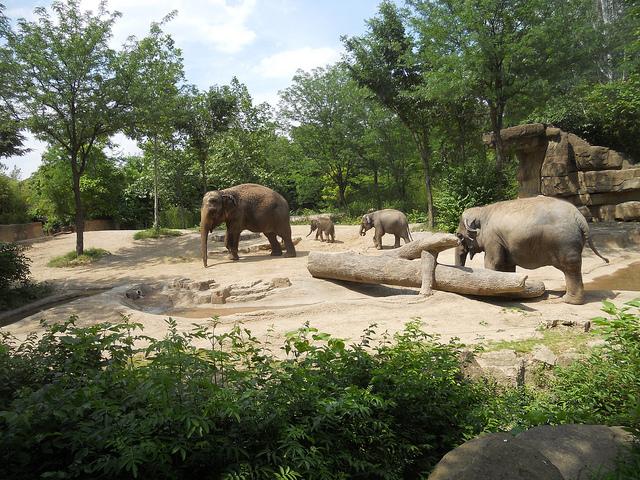Are the elephants in the jungle?
Quick response, please. No. How many elephants?
Give a very brief answer. 4. Is there a fallen tree in the picture?
Give a very brief answer. Yes. What are the elephants walking on?
Keep it brief. Sand. 